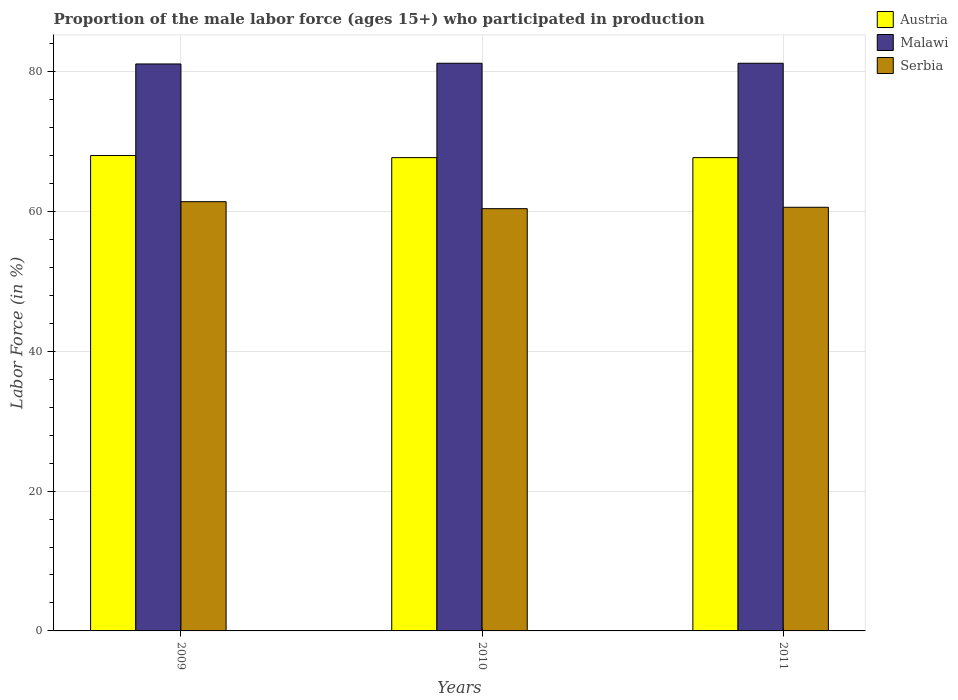How many different coloured bars are there?
Ensure brevity in your answer.  3. How many groups of bars are there?
Ensure brevity in your answer.  3. Are the number of bars per tick equal to the number of legend labels?
Your response must be concise. Yes. What is the proportion of the male labor force who participated in production in Serbia in 2009?
Offer a terse response. 61.4. Across all years, what is the maximum proportion of the male labor force who participated in production in Malawi?
Your response must be concise. 81.2. Across all years, what is the minimum proportion of the male labor force who participated in production in Malawi?
Your answer should be very brief. 81.1. In which year was the proportion of the male labor force who participated in production in Malawi maximum?
Your answer should be very brief. 2010. What is the total proportion of the male labor force who participated in production in Malawi in the graph?
Your answer should be very brief. 243.5. What is the difference between the proportion of the male labor force who participated in production in Austria in 2009 and that in 2010?
Provide a succinct answer. 0.3. What is the difference between the proportion of the male labor force who participated in production in Austria in 2010 and the proportion of the male labor force who participated in production in Malawi in 2009?
Provide a short and direct response. -13.4. What is the average proportion of the male labor force who participated in production in Malawi per year?
Your answer should be compact. 81.17. In the year 2011, what is the difference between the proportion of the male labor force who participated in production in Austria and proportion of the male labor force who participated in production in Serbia?
Offer a terse response. 7.1. What is the difference between the highest and the second highest proportion of the male labor force who participated in production in Austria?
Make the answer very short. 0.3. What is the difference between the highest and the lowest proportion of the male labor force who participated in production in Malawi?
Ensure brevity in your answer.  0.1. What does the 2nd bar from the right in 2009 represents?
Your answer should be compact. Malawi. Is it the case that in every year, the sum of the proportion of the male labor force who participated in production in Austria and proportion of the male labor force who participated in production in Malawi is greater than the proportion of the male labor force who participated in production in Serbia?
Keep it short and to the point. Yes. How many years are there in the graph?
Your answer should be very brief. 3. How many legend labels are there?
Provide a succinct answer. 3. What is the title of the graph?
Keep it short and to the point. Proportion of the male labor force (ages 15+) who participated in production. Does "Euro area" appear as one of the legend labels in the graph?
Make the answer very short. No. What is the label or title of the Y-axis?
Ensure brevity in your answer.  Labor Force (in %). What is the Labor Force (in %) of Austria in 2009?
Offer a terse response. 68. What is the Labor Force (in %) of Malawi in 2009?
Offer a very short reply. 81.1. What is the Labor Force (in %) in Serbia in 2009?
Offer a terse response. 61.4. What is the Labor Force (in %) in Austria in 2010?
Ensure brevity in your answer.  67.7. What is the Labor Force (in %) in Malawi in 2010?
Provide a succinct answer. 81.2. What is the Labor Force (in %) in Serbia in 2010?
Give a very brief answer. 60.4. What is the Labor Force (in %) in Austria in 2011?
Your answer should be very brief. 67.7. What is the Labor Force (in %) in Malawi in 2011?
Ensure brevity in your answer.  81.2. What is the Labor Force (in %) of Serbia in 2011?
Offer a terse response. 60.6. Across all years, what is the maximum Labor Force (in %) in Malawi?
Make the answer very short. 81.2. Across all years, what is the maximum Labor Force (in %) in Serbia?
Provide a short and direct response. 61.4. Across all years, what is the minimum Labor Force (in %) in Austria?
Your response must be concise. 67.7. Across all years, what is the minimum Labor Force (in %) of Malawi?
Offer a terse response. 81.1. Across all years, what is the minimum Labor Force (in %) of Serbia?
Give a very brief answer. 60.4. What is the total Labor Force (in %) of Austria in the graph?
Offer a terse response. 203.4. What is the total Labor Force (in %) of Malawi in the graph?
Your answer should be compact. 243.5. What is the total Labor Force (in %) of Serbia in the graph?
Give a very brief answer. 182.4. What is the difference between the Labor Force (in %) in Serbia in 2009 and that in 2010?
Your answer should be compact. 1. What is the difference between the Labor Force (in %) in Malawi in 2009 and that in 2011?
Provide a short and direct response. -0.1. What is the difference between the Labor Force (in %) of Malawi in 2010 and that in 2011?
Ensure brevity in your answer.  0. What is the difference between the Labor Force (in %) of Austria in 2009 and the Labor Force (in %) of Malawi in 2010?
Make the answer very short. -13.2. What is the difference between the Labor Force (in %) of Malawi in 2009 and the Labor Force (in %) of Serbia in 2010?
Ensure brevity in your answer.  20.7. What is the difference between the Labor Force (in %) of Malawi in 2009 and the Labor Force (in %) of Serbia in 2011?
Make the answer very short. 20.5. What is the difference between the Labor Force (in %) of Austria in 2010 and the Labor Force (in %) of Malawi in 2011?
Offer a very short reply. -13.5. What is the difference between the Labor Force (in %) in Malawi in 2010 and the Labor Force (in %) in Serbia in 2011?
Offer a terse response. 20.6. What is the average Labor Force (in %) in Austria per year?
Provide a succinct answer. 67.8. What is the average Labor Force (in %) of Malawi per year?
Keep it short and to the point. 81.17. What is the average Labor Force (in %) of Serbia per year?
Your answer should be very brief. 60.8. In the year 2009, what is the difference between the Labor Force (in %) in Austria and Labor Force (in %) in Serbia?
Your answer should be very brief. 6.6. In the year 2010, what is the difference between the Labor Force (in %) in Austria and Labor Force (in %) in Malawi?
Make the answer very short. -13.5. In the year 2010, what is the difference between the Labor Force (in %) in Austria and Labor Force (in %) in Serbia?
Make the answer very short. 7.3. In the year 2010, what is the difference between the Labor Force (in %) of Malawi and Labor Force (in %) of Serbia?
Give a very brief answer. 20.8. In the year 2011, what is the difference between the Labor Force (in %) in Austria and Labor Force (in %) in Malawi?
Keep it short and to the point. -13.5. In the year 2011, what is the difference between the Labor Force (in %) of Malawi and Labor Force (in %) of Serbia?
Your answer should be compact. 20.6. What is the ratio of the Labor Force (in %) of Malawi in 2009 to that in 2010?
Provide a succinct answer. 1. What is the ratio of the Labor Force (in %) of Serbia in 2009 to that in 2010?
Make the answer very short. 1.02. What is the ratio of the Labor Force (in %) in Austria in 2009 to that in 2011?
Your answer should be very brief. 1. What is the ratio of the Labor Force (in %) in Malawi in 2009 to that in 2011?
Keep it short and to the point. 1. What is the ratio of the Labor Force (in %) in Serbia in 2009 to that in 2011?
Provide a succinct answer. 1.01. What is the ratio of the Labor Force (in %) in Austria in 2010 to that in 2011?
Provide a succinct answer. 1. What is the ratio of the Labor Force (in %) of Serbia in 2010 to that in 2011?
Your answer should be compact. 1. What is the difference between the highest and the second highest Labor Force (in %) of Serbia?
Provide a succinct answer. 0.8. 